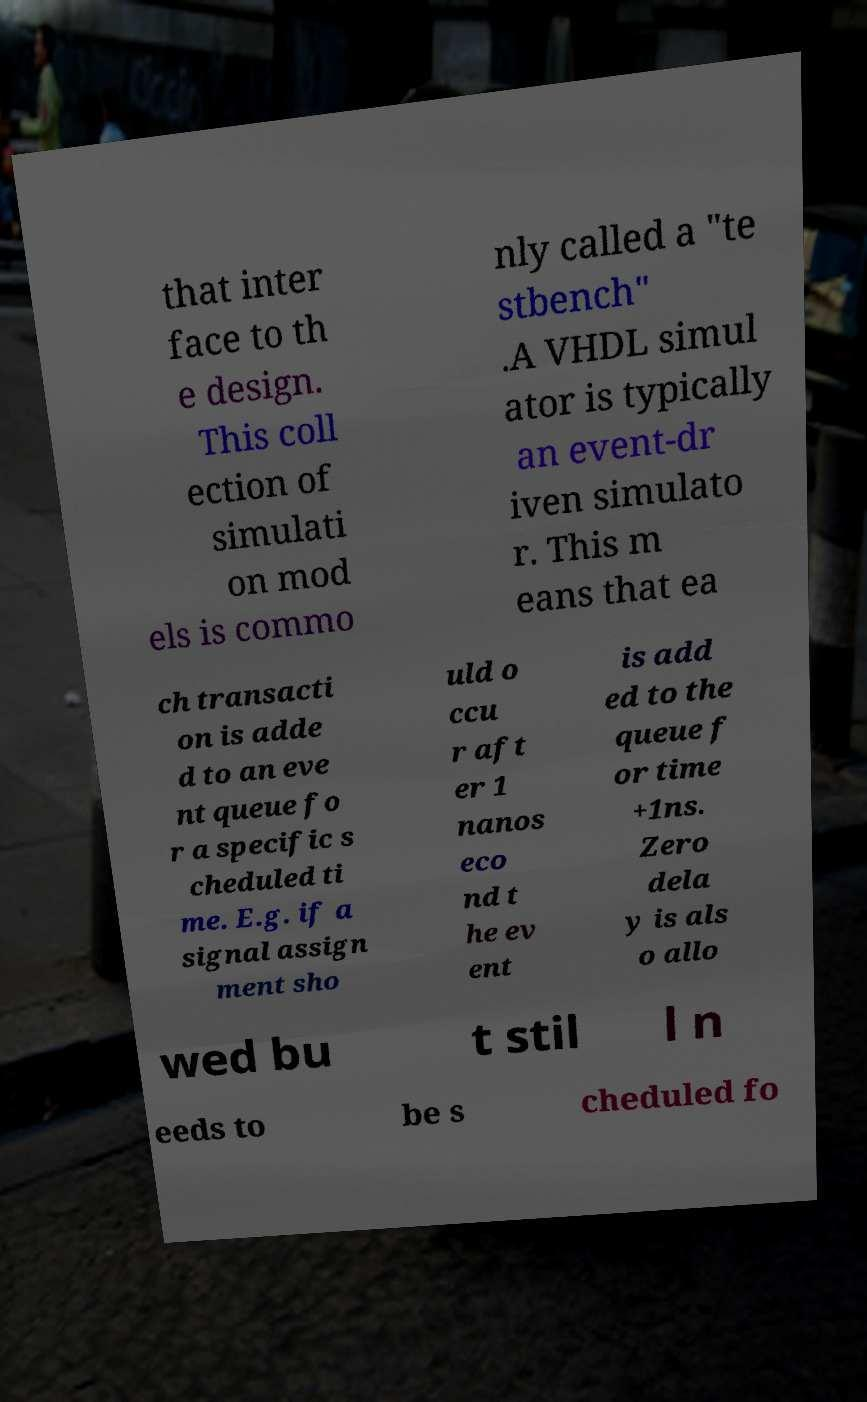Could you assist in decoding the text presented in this image and type it out clearly? that inter face to th e design. This coll ection of simulati on mod els is commo nly called a "te stbench" .A VHDL simul ator is typically an event-dr iven simulato r. This m eans that ea ch transacti on is adde d to an eve nt queue fo r a specific s cheduled ti me. E.g. if a signal assign ment sho uld o ccu r aft er 1 nanos eco nd t he ev ent is add ed to the queue f or time +1ns. Zero dela y is als o allo wed bu t stil l n eeds to be s cheduled fo 